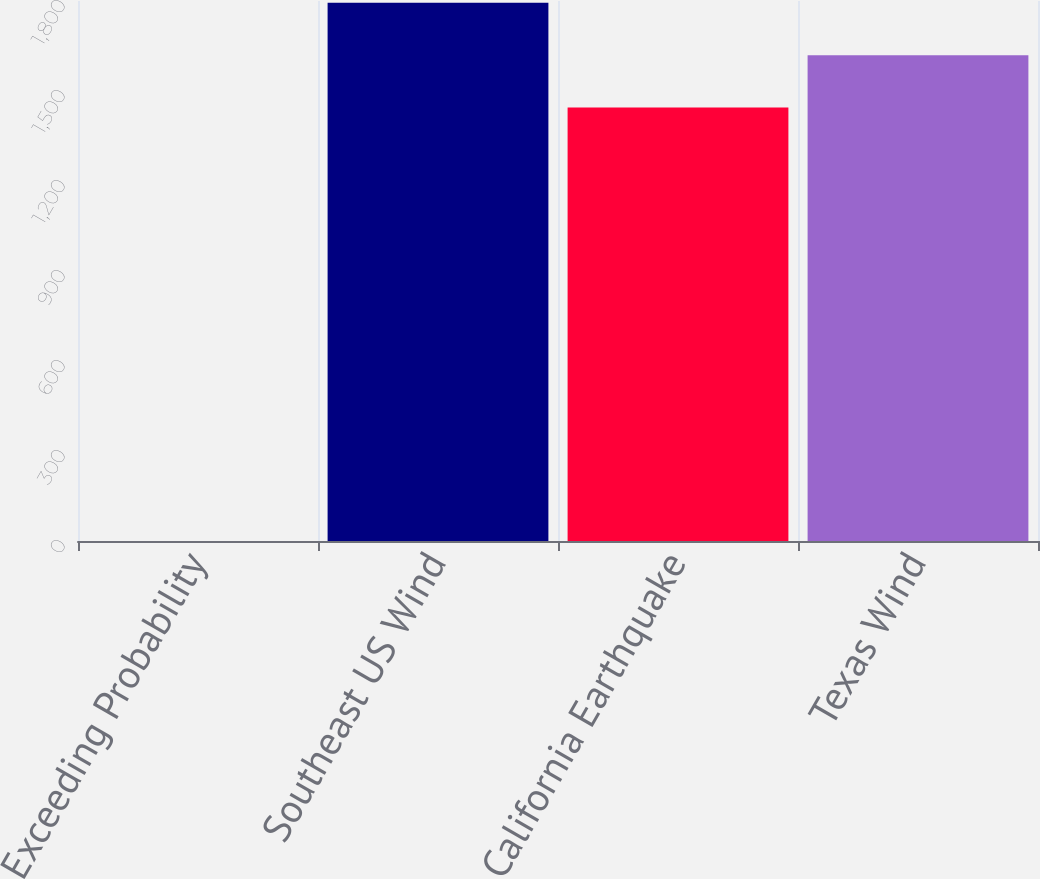Convert chart to OTSL. <chart><loc_0><loc_0><loc_500><loc_500><bar_chart><fcel>Exceeding Probability<fcel>Southeast US Wind<fcel>California Earthquake<fcel>Texas Wind<nl><fcel>0.4<fcel>1793.92<fcel>1445<fcel>1619.46<nl></chart> 